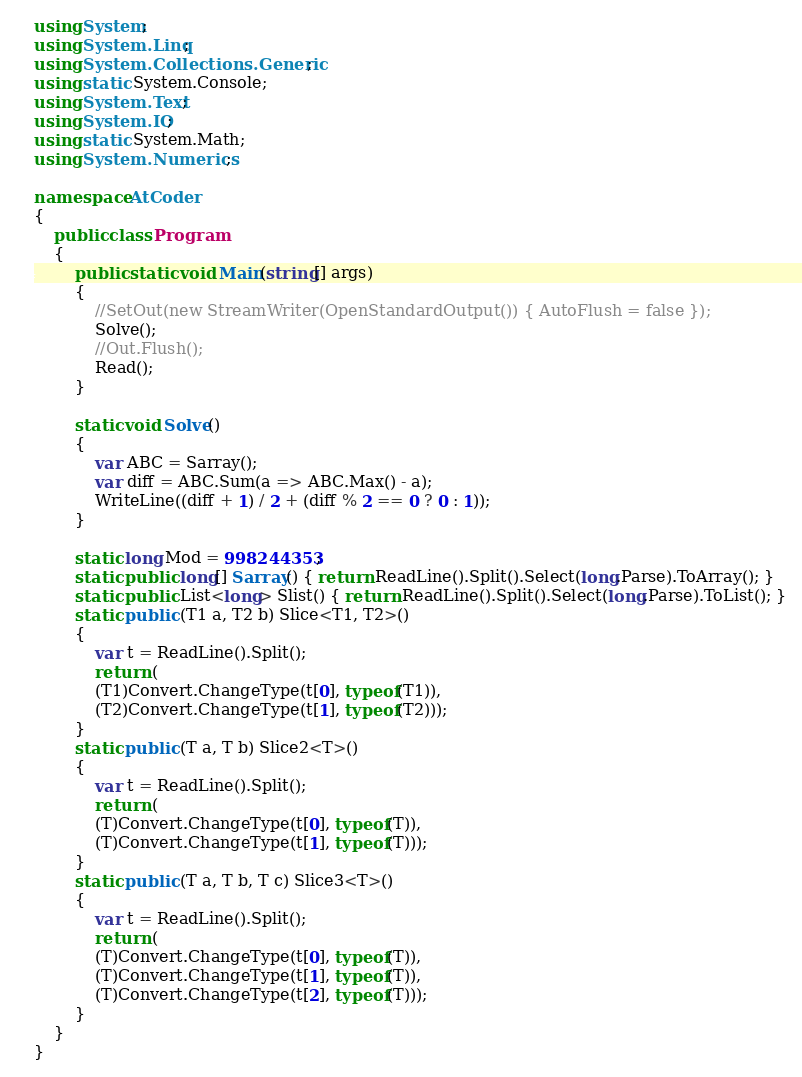<code> <loc_0><loc_0><loc_500><loc_500><_C#_>using System;
using System.Linq;
using System.Collections.Generic;
using static System.Console;
using System.Text;
using System.IO;
using static System.Math;
using System.Numerics;

namespace AtCoder
{
    public class Program
    {
        public static void Main(string[] args)
        {
            //SetOut(new StreamWriter(OpenStandardOutput()) { AutoFlush = false });
            Solve();
            //Out.Flush();
            Read();
        }

        static void Solve()
        {
            var ABC = Sarray();
            var diff = ABC.Sum(a => ABC.Max() - a);
            WriteLine((diff + 1) / 2 + (diff % 2 == 0 ? 0 : 1));
        }

        static long Mod = 998244353;
        static public long[] Sarray() { return ReadLine().Split().Select(long.Parse).ToArray(); }
        static public List<long> Slist() { return ReadLine().Split().Select(long.Parse).ToList(); }
        static public (T1 a, T2 b) Slice<T1, T2>()
        {
            var t = ReadLine().Split();
            return (
            (T1)Convert.ChangeType(t[0], typeof(T1)),
            (T2)Convert.ChangeType(t[1], typeof(T2)));
        }
        static public (T a, T b) Slice2<T>()
        {
            var t = ReadLine().Split();
            return (
            (T)Convert.ChangeType(t[0], typeof(T)),
            (T)Convert.ChangeType(t[1], typeof(T)));
        }
        static public (T a, T b, T c) Slice3<T>()
        {
            var t = ReadLine().Split();
            return (
            (T)Convert.ChangeType(t[0], typeof(T)),
            (T)Convert.ChangeType(t[1], typeof(T)),
            (T)Convert.ChangeType(t[2], typeof(T)));
        }
    }
}</code> 